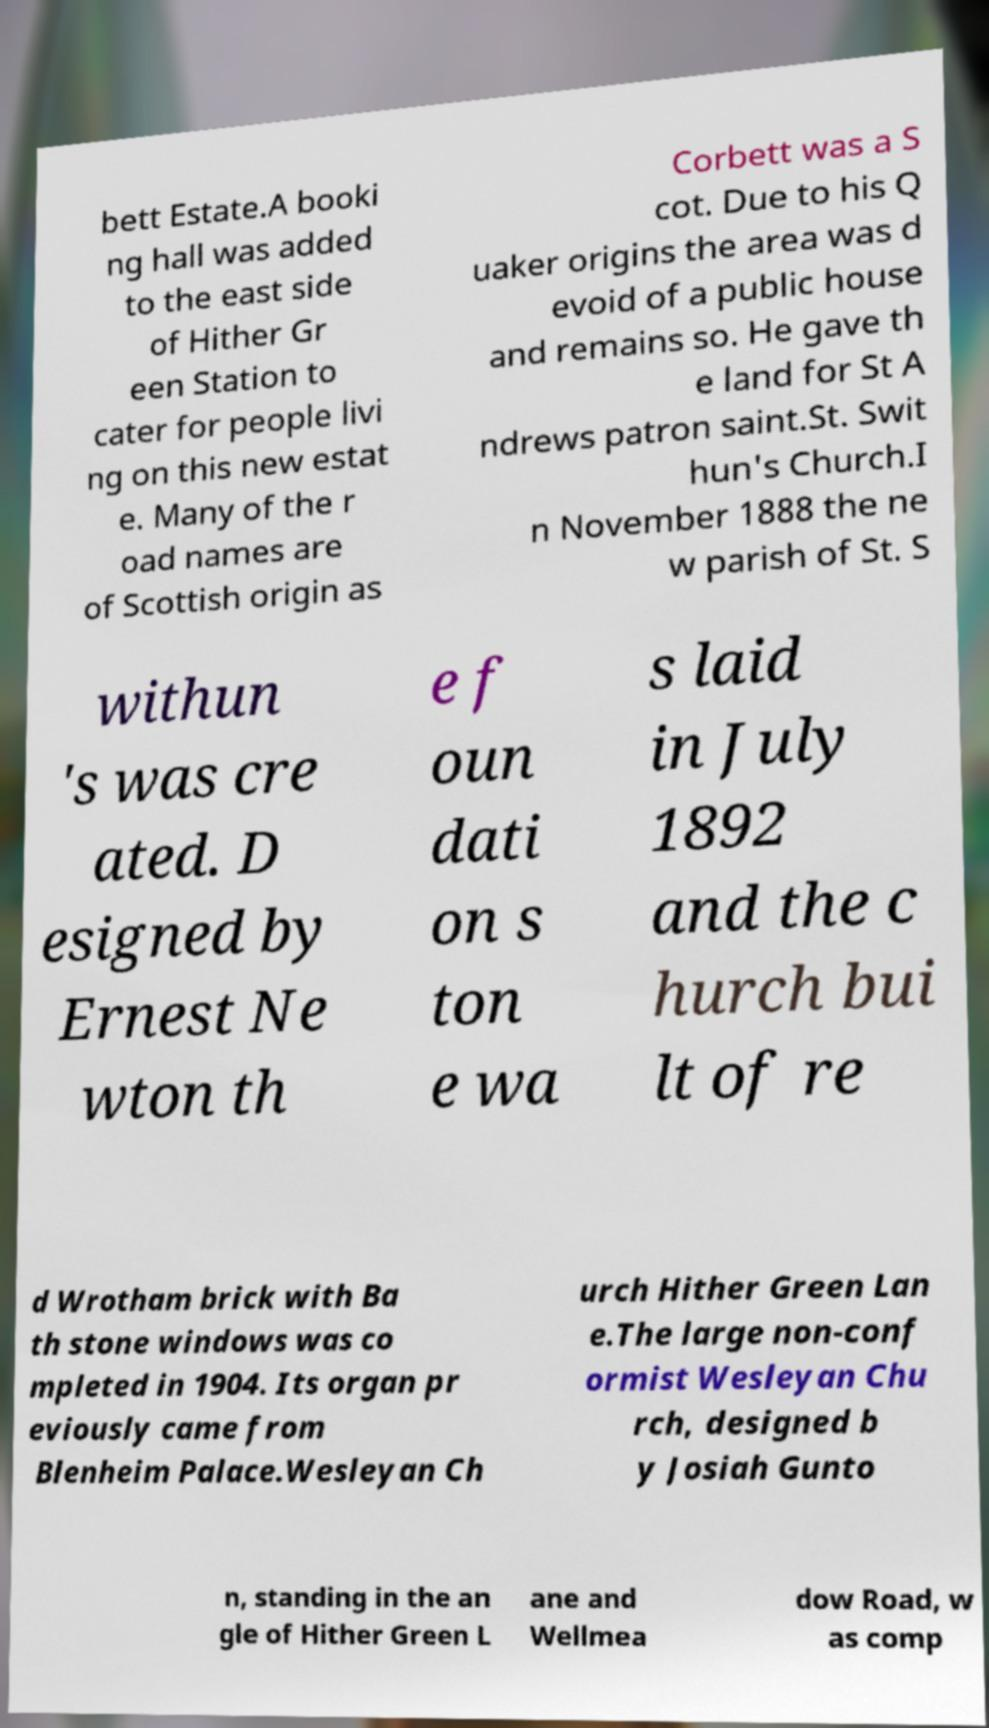What messages or text are displayed in this image? I need them in a readable, typed format. bett Estate.A booki ng hall was added to the east side of Hither Gr een Station to cater for people livi ng on this new estat e. Many of the r oad names are of Scottish origin as Corbett was a S cot. Due to his Q uaker origins the area was d evoid of a public house and remains so. He gave th e land for St A ndrews patron saint.St. Swit hun's Church.I n November 1888 the ne w parish of St. S withun 's was cre ated. D esigned by Ernest Ne wton th e f oun dati on s ton e wa s laid in July 1892 and the c hurch bui lt of re d Wrotham brick with Ba th stone windows was co mpleted in 1904. Its organ pr eviously came from Blenheim Palace.Wesleyan Ch urch Hither Green Lan e.The large non-conf ormist Wesleyan Chu rch, designed b y Josiah Gunto n, standing in the an gle of Hither Green L ane and Wellmea dow Road, w as comp 